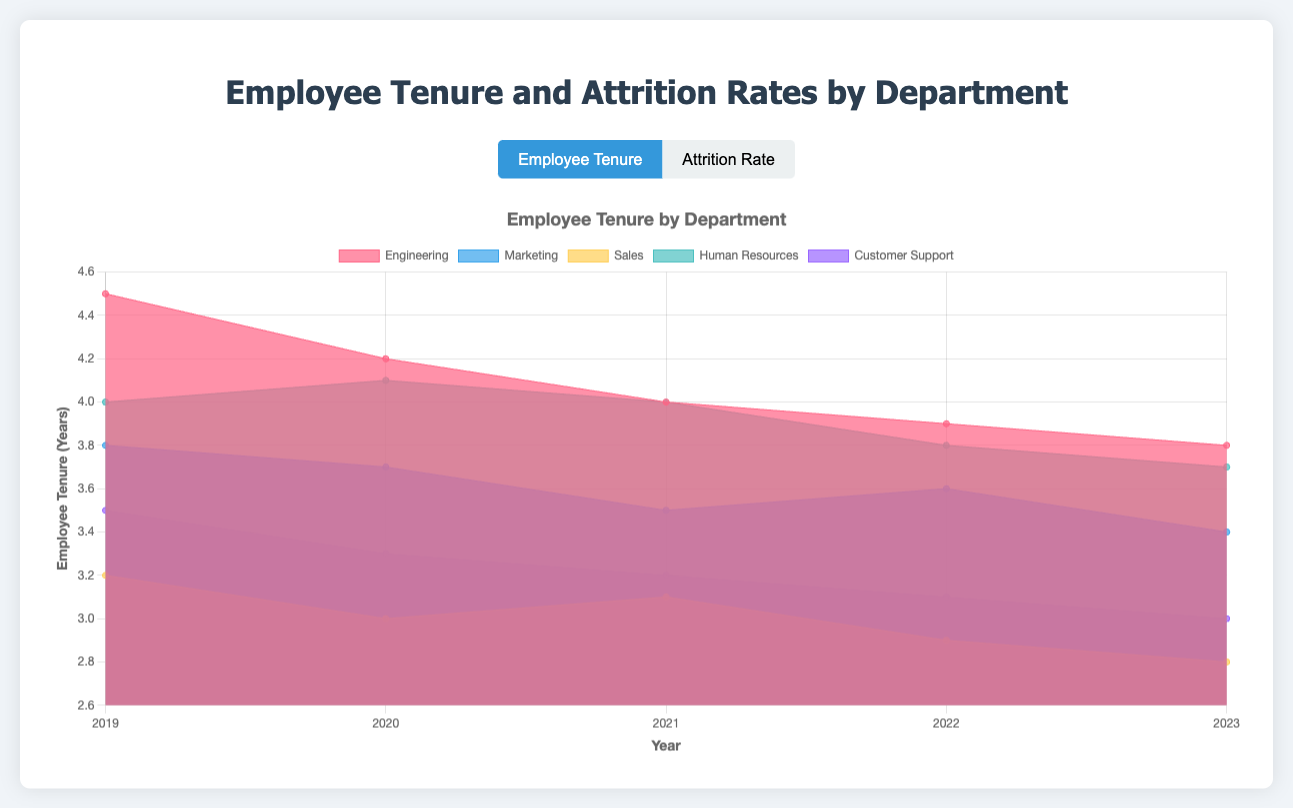What's the title of the chart for employee tenure? The title of the chart for employee tenure is displayed at the top of the chart and reads "Employee Tenure by Department."
Answer: Employee Tenure by Department Which department had the highest attrition rate in 2023? Looking at the attrition rates for each department in 2023, Customer Support had the highest attrition rate compared to other departments.
Answer: Customer Support Between which two years did the Engineering department see the largest decrease in employee tenure? Compare the tenure values between consecutive years for Engineering. The most significant drop occurred between 2019 (4.5 years) and 2020 (4.2 years), a difference of 0.3 years.
Answer: 2019 and 2020 What is the average attrition rate for the Sales department over the five years? Sum the attrition rates for Sales from 2019 to 2023 (0.20 + 0.21 + 0.23 + 0.25 + 0.26) = 1.15. Then, divide by 5 to find the average: 1.15 / 5 = 0.23.
Answer: 0.23 (or 23%) How does the employee tenure trend in the Marketing department compare to the trend in the Human Resources department over the five years? The Marketing department's tenure decreases from 3.8 to 3.4 years. The HR department also shows a decreasing trend from 4.0 to 3.7 years, but the Marketing department has a more noticeable decline overall.
Answer: Both departments show a decreasing trend, but Marketing has a more noticeable decline Which department had the lowest average employee tenure in 2021? Compare the employee tenure in 2021 across all departments. Sales had the lowest tenure with 3.1 years.
Answer: Sales Is there a positive correlation between employee tenure and attrition rate for the Customer Support department? Observing Customer Support data, as the employee tenure decreases from 3.5 to 3.0 years from 2019 to 2023, the attrition rate increases from 0.22 to 0.27. This indicates a negative correlation.
Answer: No, there is a negative correlation In which year did the Human Resources department have the lowest attrition rate? The attrition rate for Human Resources is lowest in 2020 at 0.13.
Answer: 2020 How much did the tenure of the Engineering department change from 2019 to 2023? Subtracting the tenure in 2023 (3.8 years) from the tenure in 2019 (4.5 years) gives a total change of 0.7 years.
Answer: 0.7 years 